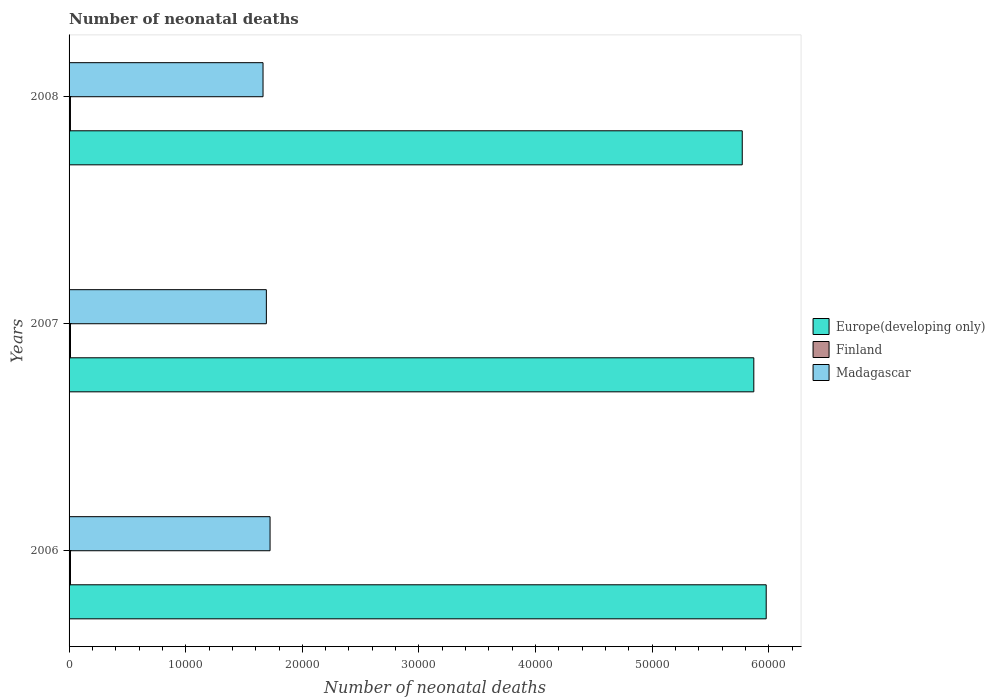How many different coloured bars are there?
Ensure brevity in your answer.  3. Are the number of bars on each tick of the Y-axis equal?
Ensure brevity in your answer.  Yes. How many bars are there on the 3rd tick from the top?
Make the answer very short. 3. What is the label of the 1st group of bars from the top?
Your answer should be compact. 2008. In how many cases, is the number of bars for a given year not equal to the number of legend labels?
Your answer should be compact. 0. What is the number of neonatal deaths in in Finland in 2008?
Your answer should be very brief. 118. Across all years, what is the maximum number of neonatal deaths in in Finland?
Ensure brevity in your answer.  123. Across all years, what is the minimum number of neonatal deaths in in Europe(developing only)?
Offer a terse response. 5.77e+04. What is the total number of neonatal deaths in in Finland in the graph?
Offer a terse response. 362. What is the difference between the number of neonatal deaths in in Europe(developing only) in 2006 and that in 2007?
Offer a terse response. 1062. What is the difference between the number of neonatal deaths in in Europe(developing only) in 2006 and the number of neonatal deaths in in Madagascar in 2008?
Your response must be concise. 4.31e+04. What is the average number of neonatal deaths in in Madagascar per year?
Ensure brevity in your answer.  1.69e+04. In the year 2008, what is the difference between the number of neonatal deaths in in Finland and number of neonatal deaths in in Madagascar?
Offer a terse response. -1.65e+04. What is the ratio of the number of neonatal deaths in in Madagascar in 2007 to that in 2008?
Give a very brief answer. 1.02. Is the number of neonatal deaths in in Europe(developing only) in 2006 less than that in 2007?
Your answer should be very brief. No. Is the difference between the number of neonatal deaths in in Finland in 2007 and 2008 greater than the difference between the number of neonatal deaths in in Madagascar in 2007 and 2008?
Keep it short and to the point. No. What is the difference between the highest and the lowest number of neonatal deaths in in Finland?
Your answer should be very brief. 5. What does the 3rd bar from the top in 2007 represents?
Provide a short and direct response. Europe(developing only). What does the 2nd bar from the bottom in 2006 represents?
Offer a terse response. Finland. Is it the case that in every year, the sum of the number of neonatal deaths in in Madagascar and number of neonatal deaths in in Europe(developing only) is greater than the number of neonatal deaths in in Finland?
Keep it short and to the point. Yes. How many bars are there?
Keep it short and to the point. 9. Are all the bars in the graph horizontal?
Offer a terse response. Yes. How many years are there in the graph?
Keep it short and to the point. 3. Are the values on the major ticks of X-axis written in scientific E-notation?
Provide a short and direct response. No. Does the graph contain any zero values?
Make the answer very short. No. Does the graph contain grids?
Your answer should be compact. No. Where does the legend appear in the graph?
Keep it short and to the point. Center right. How many legend labels are there?
Your answer should be very brief. 3. How are the legend labels stacked?
Your answer should be compact. Vertical. What is the title of the graph?
Your answer should be very brief. Number of neonatal deaths. Does "Ethiopia" appear as one of the legend labels in the graph?
Offer a very short reply. No. What is the label or title of the X-axis?
Make the answer very short. Number of neonatal deaths. What is the Number of neonatal deaths of Europe(developing only) in 2006?
Ensure brevity in your answer.  5.98e+04. What is the Number of neonatal deaths in Finland in 2006?
Offer a terse response. 121. What is the Number of neonatal deaths of Madagascar in 2006?
Your answer should be very brief. 1.72e+04. What is the Number of neonatal deaths of Europe(developing only) in 2007?
Your answer should be compact. 5.87e+04. What is the Number of neonatal deaths of Finland in 2007?
Give a very brief answer. 123. What is the Number of neonatal deaths of Madagascar in 2007?
Keep it short and to the point. 1.69e+04. What is the Number of neonatal deaths of Europe(developing only) in 2008?
Your response must be concise. 5.77e+04. What is the Number of neonatal deaths in Finland in 2008?
Provide a short and direct response. 118. What is the Number of neonatal deaths in Madagascar in 2008?
Provide a short and direct response. 1.66e+04. Across all years, what is the maximum Number of neonatal deaths in Europe(developing only)?
Provide a short and direct response. 5.98e+04. Across all years, what is the maximum Number of neonatal deaths in Finland?
Provide a short and direct response. 123. Across all years, what is the maximum Number of neonatal deaths of Madagascar?
Make the answer very short. 1.72e+04. Across all years, what is the minimum Number of neonatal deaths in Europe(developing only)?
Offer a terse response. 5.77e+04. Across all years, what is the minimum Number of neonatal deaths of Finland?
Ensure brevity in your answer.  118. Across all years, what is the minimum Number of neonatal deaths in Madagascar?
Provide a succinct answer. 1.66e+04. What is the total Number of neonatal deaths of Europe(developing only) in the graph?
Offer a very short reply. 1.76e+05. What is the total Number of neonatal deaths in Finland in the graph?
Your answer should be compact. 362. What is the total Number of neonatal deaths of Madagascar in the graph?
Make the answer very short. 5.08e+04. What is the difference between the Number of neonatal deaths in Europe(developing only) in 2006 and that in 2007?
Your answer should be compact. 1062. What is the difference between the Number of neonatal deaths of Madagascar in 2006 and that in 2007?
Offer a terse response. 318. What is the difference between the Number of neonatal deaths of Europe(developing only) in 2006 and that in 2008?
Your response must be concise. 2054. What is the difference between the Number of neonatal deaths of Finland in 2006 and that in 2008?
Make the answer very short. 3. What is the difference between the Number of neonatal deaths of Madagascar in 2006 and that in 2008?
Ensure brevity in your answer.  603. What is the difference between the Number of neonatal deaths of Europe(developing only) in 2007 and that in 2008?
Offer a very short reply. 992. What is the difference between the Number of neonatal deaths in Finland in 2007 and that in 2008?
Provide a short and direct response. 5. What is the difference between the Number of neonatal deaths in Madagascar in 2007 and that in 2008?
Provide a succinct answer. 285. What is the difference between the Number of neonatal deaths of Europe(developing only) in 2006 and the Number of neonatal deaths of Finland in 2007?
Your answer should be compact. 5.97e+04. What is the difference between the Number of neonatal deaths of Europe(developing only) in 2006 and the Number of neonatal deaths of Madagascar in 2007?
Provide a succinct answer. 4.29e+04. What is the difference between the Number of neonatal deaths of Finland in 2006 and the Number of neonatal deaths of Madagascar in 2007?
Provide a succinct answer. -1.68e+04. What is the difference between the Number of neonatal deaths of Europe(developing only) in 2006 and the Number of neonatal deaths of Finland in 2008?
Your answer should be very brief. 5.97e+04. What is the difference between the Number of neonatal deaths of Europe(developing only) in 2006 and the Number of neonatal deaths of Madagascar in 2008?
Provide a succinct answer. 4.31e+04. What is the difference between the Number of neonatal deaths of Finland in 2006 and the Number of neonatal deaths of Madagascar in 2008?
Your answer should be very brief. -1.65e+04. What is the difference between the Number of neonatal deaths in Europe(developing only) in 2007 and the Number of neonatal deaths in Finland in 2008?
Ensure brevity in your answer.  5.86e+04. What is the difference between the Number of neonatal deaths in Europe(developing only) in 2007 and the Number of neonatal deaths in Madagascar in 2008?
Your answer should be compact. 4.21e+04. What is the difference between the Number of neonatal deaths in Finland in 2007 and the Number of neonatal deaths in Madagascar in 2008?
Provide a short and direct response. -1.65e+04. What is the average Number of neonatal deaths in Europe(developing only) per year?
Make the answer very short. 5.87e+04. What is the average Number of neonatal deaths of Finland per year?
Your answer should be compact. 120.67. What is the average Number of neonatal deaths in Madagascar per year?
Offer a very short reply. 1.69e+04. In the year 2006, what is the difference between the Number of neonatal deaths of Europe(developing only) and Number of neonatal deaths of Finland?
Offer a very short reply. 5.97e+04. In the year 2006, what is the difference between the Number of neonatal deaths in Europe(developing only) and Number of neonatal deaths in Madagascar?
Make the answer very short. 4.25e+04. In the year 2006, what is the difference between the Number of neonatal deaths of Finland and Number of neonatal deaths of Madagascar?
Make the answer very short. -1.71e+04. In the year 2007, what is the difference between the Number of neonatal deaths in Europe(developing only) and Number of neonatal deaths in Finland?
Your answer should be very brief. 5.86e+04. In the year 2007, what is the difference between the Number of neonatal deaths of Europe(developing only) and Number of neonatal deaths of Madagascar?
Provide a short and direct response. 4.18e+04. In the year 2007, what is the difference between the Number of neonatal deaths in Finland and Number of neonatal deaths in Madagascar?
Your answer should be compact. -1.68e+04. In the year 2008, what is the difference between the Number of neonatal deaths of Europe(developing only) and Number of neonatal deaths of Finland?
Ensure brevity in your answer.  5.76e+04. In the year 2008, what is the difference between the Number of neonatal deaths in Europe(developing only) and Number of neonatal deaths in Madagascar?
Your response must be concise. 4.11e+04. In the year 2008, what is the difference between the Number of neonatal deaths in Finland and Number of neonatal deaths in Madagascar?
Make the answer very short. -1.65e+04. What is the ratio of the Number of neonatal deaths in Europe(developing only) in 2006 to that in 2007?
Keep it short and to the point. 1.02. What is the ratio of the Number of neonatal deaths of Finland in 2006 to that in 2007?
Your response must be concise. 0.98. What is the ratio of the Number of neonatal deaths of Madagascar in 2006 to that in 2007?
Make the answer very short. 1.02. What is the ratio of the Number of neonatal deaths of Europe(developing only) in 2006 to that in 2008?
Give a very brief answer. 1.04. What is the ratio of the Number of neonatal deaths of Finland in 2006 to that in 2008?
Make the answer very short. 1.03. What is the ratio of the Number of neonatal deaths of Madagascar in 2006 to that in 2008?
Provide a succinct answer. 1.04. What is the ratio of the Number of neonatal deaths of Europe(developing only) in 2007 to that in 2008?
Your answer should be compact. 1.02. What is the ratio of the Number of neonatal deaths in Finland in 2007 to that in 2008?
Provide a short and direct response. 1.04. What is the ratio of the Number of neonatal deaths of Madagascar in 2007 to that in 2008?
Ensure brevity in your answer.  1.02. What is the difference between the highest and the second highest Number of neonatal deaths in Europe(developing only)?
Provide a succinct answer. 1062. What is the difference between the highest and the second highest Number of neonatal deaths in Madagascar?
Your answer should be compact. 318. What is the difference between the highest and the lowest Number of neonatal deaths of Europe(developing only)?
Your answer should be very brief. 2054. What is the difference between the highest and the lowest Number of neonatal deaths in Madagascar?
Provide a succinct answer. 603. 